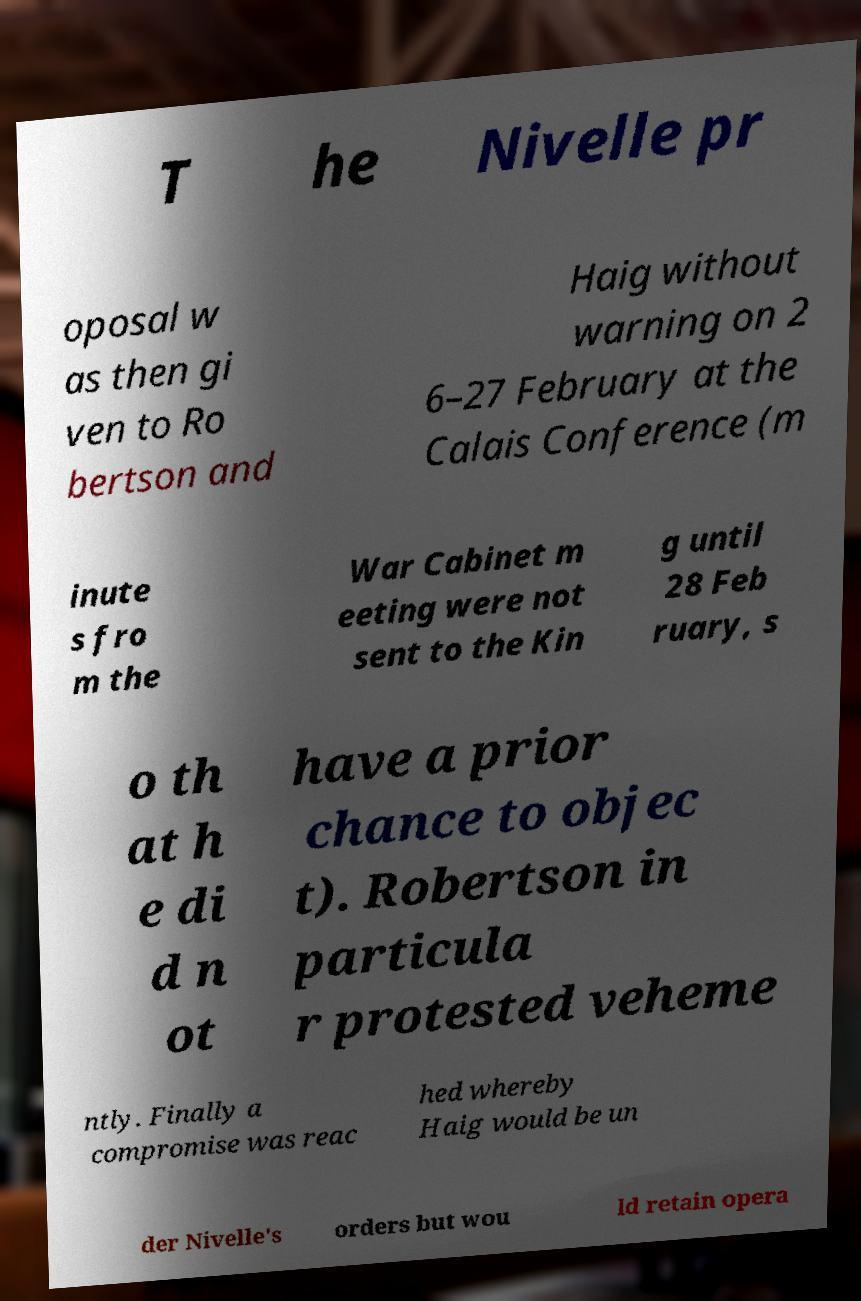Can you read and provide the text displayed in the image?This photo seems to have some interesting text. Can you extract and type it out for me? T he Nivelle pr oposal w as then gi ven to Ro bertson and Haig without warning on 2 6–27 February at the Calais Conference (m inute s fro m the War Cabinet m eeting were not sent to the Kin g until 28 Feb ruary, s o th at h e di d n ot have a prior chance to objec t). Robertson in particula r protested veheme ntly. Finally a compromise was reac hed whereby Haig would be un der Nivelle's orders but wou ld retain opera 